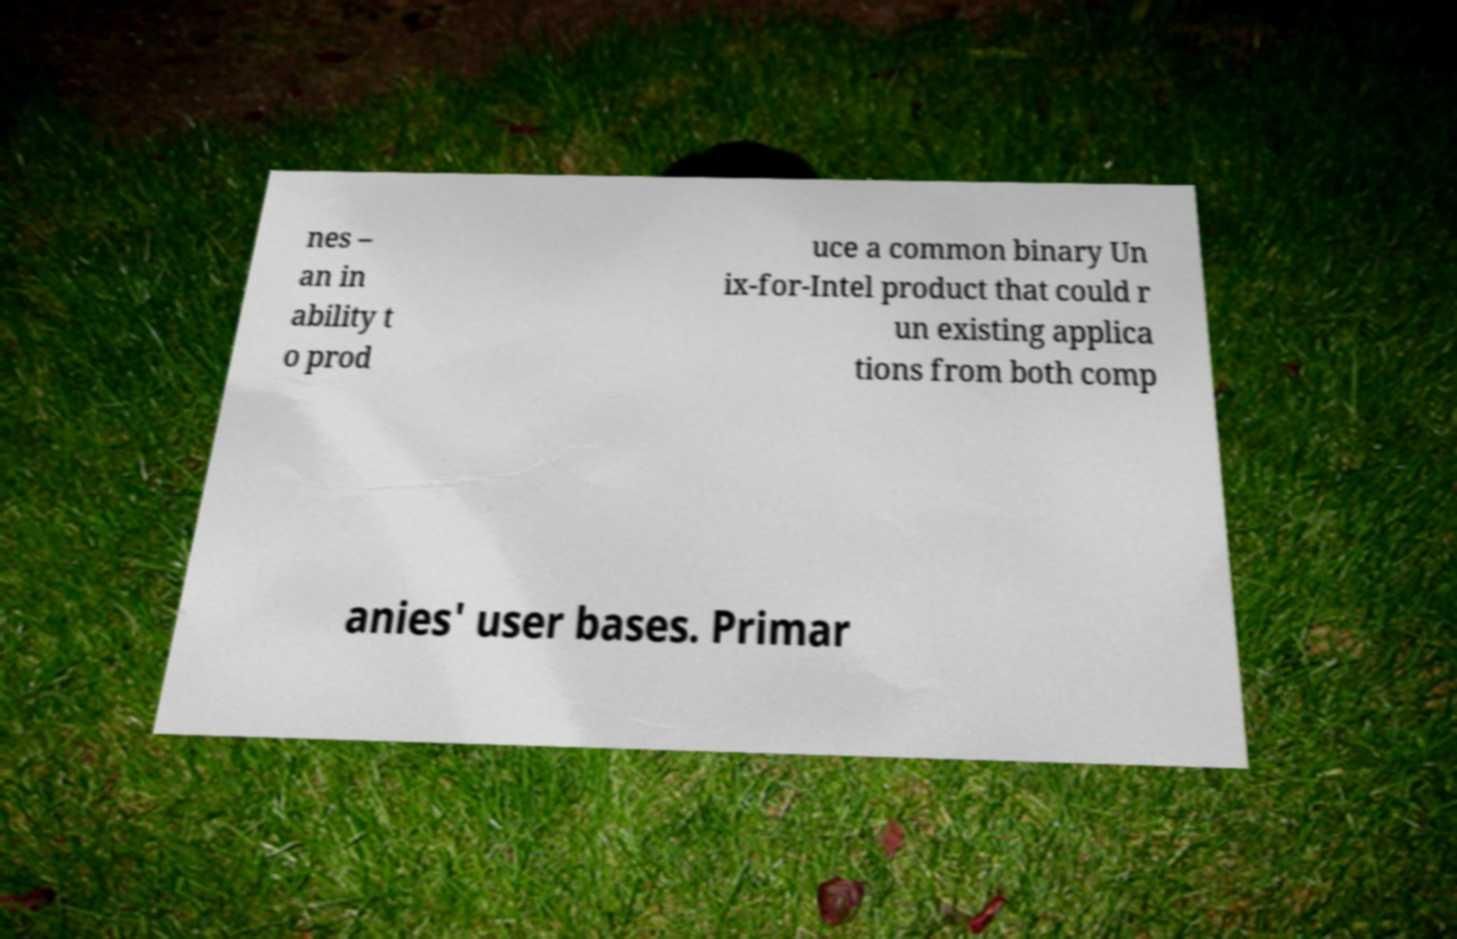Can you accurately transcribe the text from the provided image for me? nes – an in ability t o prod uce a common binary Un ix-for-Intel product that could r un existing applica tions from both comp anies' user bases. Primar 